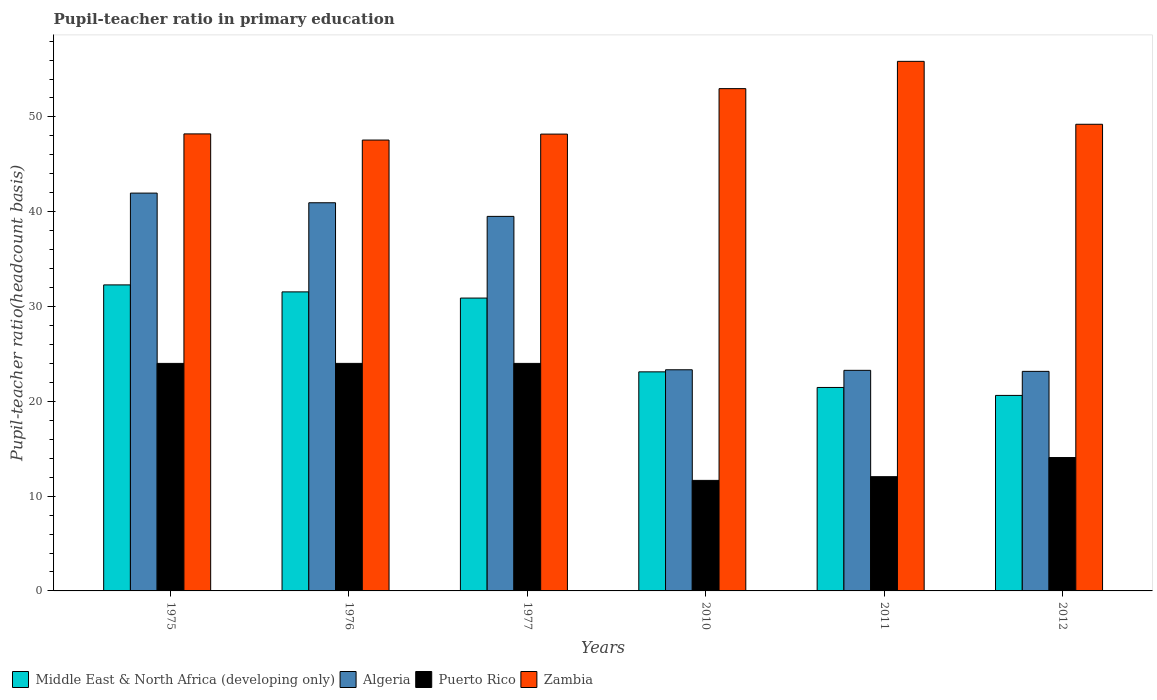How many groups of bars are there?
Provide a short and direct response. 6. Are the number of bars per tick equal to the number of legend labels?
Offer a terse response. Yes. How many bars are there on the 4th tick from the left?
Provide a short and direct response. 4. What is the label of the 1st group of bars from the left?
Ensure brevity in your answer.  1975. What is the pupil-teacher ratio in primary education in Zambia in 2012?
Provide a short and direct response. 49.22. Across all years, what is the maximum pupil-teacher ratio in primary education in Middle East & North Africa (developing only)?
Provide a short and direct response. 32.28. Across all years, what is the minimum pupil-teacher ratio in primary education in Zambia?
Offer a very short reply. 47.56. What is the total pupil-teacher ratio in primary education in Algeria in the graph?
Your response must be concise. 192.18. What is the difference between the pupil-teacher ratio in primary education in Puerto Rico in 2011 and that in 2012?
Make the answer very short. -2.02. What is the difference between the pupil-teacher ratio in primary education in Middle East & North Africa (developing only) in 2010 and the pupil-teacher ratio in primary education in Zambia in 1976?
Provide a short and direct response. -24.45. What is the average pupil-teacher ratio in primary education in Zambia per year?
Offer a terse response. 50.34. In the year 2012, what is the difference between the pupil-teacher ratio in primary education in Middle East & North Africa (developing only) and pupil-teacher ratio in primary education in Puerto Rico?
Ensure brevity in your answer.  6.55. In how many years, is the pupil-teacher ratio in primary education in Algeria greater than 20?
Give a very brief answer. 6. What is the ratio of the pupil-teacher ratio in primary education in Zambia in 1976 to that in 1977?
Offer a very short reply. 0.99. What is the difference between the highest and the second highest pupil-teacher ratio in primary education in Puerto Rico?
Ensure brevity in your answer.  0. What is the difference between the highest and the lowest pupil-teacher ratio in primary education in Algeria?
Your response must be concise. 18.8. In how many years, is the pupil-teacher ratio in primary education in Algeria greater than the average pupil-teacher ratio in primary education in Algeria taken over all years?
Provide a succinct answer. 3. Is it the case that in every year, the sum of the pupil-teacher ratio in primary education in Middle East & North Africa (developing only) and pupil-teacher ratio in primary education in Zambia is greater than the sum of pupil-teacher ratio in primary education in Puerto Rico and pupil-teacher ratio in primary education in Algeria?
Your answer should be compact. Yes. What does the 1st bar from the left in 1977 represents?
Keep it short and to the point. Middle East & North Africa (developing only). What does the 4th bar from the right in 1977 represents?
Give a very brief answer. Middle East & North Africa (developing only). Are all the bars in the graph horizontal?
Keep it short and to the point. No. How many years are there in the graph?
Your answer should be very brief. 6. Does the graph contain grids?
Provide a succinct answer. No. Where does the legend appear in the graph?
Provide a succinct answer. Bottom left. How many legend labels are there?
Offer a terse response. 4. What is the title of the graph?
Your answer should be very brief. Pupil-teacher ratio in primary education. What is the label or title of the X-axis?
Provide a short and direct response. Years. What is the label or title of the Y-axis?
Provide a succinct answer. Pupil-teacher ratio(headcount basis). What is the Pupil-teacher ratio(headcount basis) of Middle East & North Africa (developing only) in 1975?
Your response must be concise. 32.28. What is the Pupil-teacher ratio(headcount basis) in Algeria in 1975?
Provide a short and direct response. 41.96. What is the Pupil-teacher ratio(headcount basis) in Puerto Rico in 1975?
Keep it short and to the point. 24. What is the Pupil-teacher ratio(headcount basis) in Zambia in 1975?
Offer a very short reply. 48.21. What is the Pupil-teacher ratio(headcount basis) of Middle East & North Africa (developing only) in 1976?
Your answer should be compact. 31.55. What is the Pupil-teacher ratio(headcount basis) of Algeria in 1976?
Your answer should be very brief. 40.95. What is the Pupil-teacher ratio(headcount basis) in Puerto Rico in 1976?
Your answer should be very brief. 24. What is the Pupil-teacher ratio(headcount basis) in Zambia in 1976?
Keep it short and to the point. 47.56. What is the Pupil-teacher ratio(headcount basis) of Middle East & North Africa (developing only) in 1977?
Your answer should be very brief. 30.89. What is the Pupil-teacher ratio(headcount basis) of Algeria in 1977?
Offer a terse response. 39.51. What is the Pupil-teacher ratio(headcount basis) in Puerto Rico in 1977?
Your answer should be compact. 24. What is the Pupil-teacher ratio(headcount basis) in Zambia in 1977?
Your answer should be compact. 48.19. What is the Pupil-teacher ratio(headcount basis) in Middle East & North Africa (developing only) in 2010?
Provide a short and direct response. 23.11. What is the Pupil-teacher ratio(headcount basis) of Algeria in 2010?
Make the answer very short. 23.33. What is the Pupil-teacher ratio(headcount basis) of Puerto Rico in 2010?
Make the answer very short. 11.66. What is the Pupil-teacher ratio(headcount basis) in Zambia in 2010?
Keep it short and to the point. 52.99. What is the Pupil-teacher ratio(headcount basis) of Middle East & North Africa (developing only) in 2011?
Offer a very short reply. 21.46. What is the Pupil-teacher ratio(headcount basis) in Algeria in 2011?
Offer a terse response. 23.27. What is the Pupil-teacher ratio(headcount basis) in Puerto Rico in 2011?
Your answer should be compact. 12.05. What is the Pupil-teacher ratio(headcount basis) of Zambia in 2011?
Ensure brevity in your answer.  55.86. What is the Pupil-teacher ratio(headcount basis) in Middle East & North Africa (developing only) in 2012?
Your answer should be compact. 20.62. What is the Pupil-teacher ratio(headcount basis) in Algeria in 2012?
Ensure brevity in your answer.  23.16. What is the Pupil-teacher ratio(headcount basis) of Puerto Rico in 2012?
Your answer should be compact. 14.07. What is the Pupil-teacher ratio(headcount basis) in Zambia in 2012?
Your response must be concise. 49.22. Across all years, what is the maximum Pupil-teacher ratio(headcount basis) in Middle East & North Africa (developing only)?
Make the answer very short. 32.28. Across all years, what is the maximum Pupil-teacher ratio(headcount basis) in Algeria?
Ensure brevity in your answer.  41.96. Across all years, what is the maximum Pupil-teacher ratio(headcount basis) in Puerto Rico?
Give a very brief answer. 24. Across all years, what is the maximum Pupil-teacher ratio(headcount basis) of Zambia?
Provide a succinct answer. 55.86. Across all years, what is the minimum Pupil-teacher ratio(headcount basis) of Middle East & North Africa (developing only)?
Your answer should be compact. 20.62. Across all years, what is the minimum Pupil-teacher ratio(headcount basis) of Algeria?
Give a very brief answer. 23.16. Across all years, what is the minimum Pupil-teacher ratio(headcount basis) of Puerto Rico?
Offer a terse response. 11.66. Across all years, what is the minimum Pupil-teacher ratio(headcount basis) of Zambia?
Provide a succinct answer. 47.56. What is the total Pupil-teacher ratio(headcount basis) in Middle East & North Africa (developing only) in the graph?
Your answer should be compact. 159.91. What is the total Pupil-teacher ratio(headcount basis) of Algeria in the graph?
Give a very brief answer. 192.18. What is the total Pupil-teacher ratio(headcount basis) of Puerto Rico in the graph?
Provide a short and direct response. 109.78. What is the total Pupil-teacher ratio(headcount basis) of Zambia in the graph?
Give a very brief answer. 302.03. What is the difference between the Pupil-teacher ratio(headcount basis) in Middle East & North Africa (developing only) in 1975 and that in 1976?
Provide a succinct answer. 0.74. What is the difference between the Pupil-teacher ratio(headcount basis) of Algeria in 1975 and that in 1976?
Offer a very short reply. 1.02. What is the difference between the Pupil-teacher ratio(headcount basis) in Puerto Rico in 1975 and that in 1976?
Make the answer very short. -0. What is the difference between the Pupil-teacher ratio(headcount basis) of Zambia in 1975 and that in 1976?
Give a very brief answer. 0.65. What is the difference between the Pupil-teacher ratio(headcount basis) of Middle East & North Africa (developing only) in 1975 and that in 1977?
Your response must be concise. 1.39. What is the difference between the Pupil-teacher ratio(headcount basis) of Algeria in 1975 and that in 1977?
Your response must be concise. 2.46. What is the difference between the Pupil-teacher ratio(headcount basis) in Zambia in 1975 and that in 1977?
Ensure brevity in your answer.  0.02. What is the difference between the Pupil-teacher ratio(headcount basis) of Middle East & North Africa (developing only) in 1975 and that in 2010?
Make the answer very short. 9.17. What is the difference between the Pupil-teacher ratio(headcount basis) in Algeria in 1975 and that in 2010?
Your answer should be compact. 18.64. What is the difference between the Pupil-teacher ratio(headcount basis) of Puerto Rico in 1975 and that in 2010?
Offer a very short reply. 12.34. What is the difference between the Pupil-teacher ratio(headcount basis) of Zambia in 1975 and that in 2010?
Your response must be concise. -4.78. What is the difference between the Pupil-teacher ratio(headcount basis) in Middle East & North Africa (developing only) in 1975 and that in 2011?
Offer a very short reply. 10.82. What is the difference between the Pupil-teacher ratio(headcount basis) in Algeria in 1975 and that in 2011?
Keep it short and to the point. 18.7. What is the difference between the Pupil-teacher ratio(headcount basis) of Puerto Rico in 1975 and that in 2011?
Provide a succinct answer. 11.95. What is the difference between the Pupil-teacher ratio(headcount basis) of Zambia in 1975 and that in 2011?
Provide a short and direct response. -7.65. What is the difference between the Pupil-teacher ratio(headcount basis) in Middle East & North Africa (developing only) in 1975 and that in 2012?
Make the answer very short. 11.66. What is the difference between the Pupil-teacher ratio(headcount basis) in Algeria in 1975 and that in 2012?
Provide a succinct answer. 18.8. What is the difference between the Pupil-teacher ratio(headcount basis) of Puerto Rico in 1975 and that in 2012?
Make the answer very short. 9.93. What is the difference between the Pupil-teacher ratio(headcount basis) of Zambia in 1975 and that in 2012?
Ensure brevity in your answer.  -1.02. What is the difference between the Pupil-teacher ratio(headcount basis) in Middle East & North Africa (developing only) in 1976 and that in 1977?
Provide a short and direct response. 0.65. What is the difference between the Pupil-teacher ratio(headcount basis) of Algeria in 1976 and that in 1977?
Provide a short and direct response. 1.44. What is the difference between the Pupil-teacher ratio(headcount basis) in Puerto Rico in 1976 and that in 1977?
Make the answer very short. 0. What is the difference between the Pupil-teacher ratio(headcount basis) of Zambia in 1976 and that in 1977?
Your response must be concise. -0.63. What is the difference between the Pupil-teacher ratio(headcount basis) of Middle East & North Africa (developing only) in 1976 and that in 2010?
Keep it short and to the point. 8.44. What is the difference between the Pupil-teacher ratio(headcount basis) of Algeria in 1976 and that in 2010?
Offer a very short reply. 17.62. What is the difference between the Pupil-teacher ratio(headcount basis) of Puerto Rico in 1976 and that in 2010?
Offer a terse response. 12.34. What is the difference between the Pupil-teacher ratio(headcount basis) of Zambia in 1976 and that in 2010?
Provide a short and direct response. -5.43. What is the difference between the Pupil-teacher ratio(headcount basis) in Middle East & North Africa (developing only) in 1976 and that in 2011?
Provide a short and direct response. 10.08. What is the difference between the Pupil-teacher ratio(headcount basis) of Algeria in 1976 and that in 2011?
Make the answer very short. 17.68. What is the difference between the Pupil-teacher ratio(headcount basis) of Puerto Rico in 1976 and that in 2011?
Your answer should be compact. 11.95. What is the difference between the Pupil-teacher ratio(headcount basis) of Zambia in 1976 and that in 2011?
Give a very brief answer. -8.3. What is the difference between the Pupil-teacher ratio(headcount basis) of Middle East & North Africa (developing only) in 1976 and that in 2012?
Provide a short and direct response. 10.92. What is the difference between the Pupil-teacher ratio(headcount basis) of Algeria in 1976 and that in 2012?
Keep it short and to the point. 17.79. What is the difference between the Pupil-teacher ratio(headcount basis) in Puerto Rico in 1976 and that in 2012?
Provide a short and direct response. 9.93. What is the difference between the Pupil-teacher ratio(headcount basis) of Zambia in 1976 and that in 2012?
Your answer should be very brief. -1.66. What is the difference between the Pupil-teacher ratio(headcount basis) in Middle East & North Africa (developing only) in 1977 and that in 2010?
Provide a short and direct response. 7.78. What is the difference between the Pupil-teacher ratio(headcount basis) in Algeria in 1977 and that in 2010?
Offer a terse response. 16.18. What is the difference between the Pupil-teacher ratio(headcount basis) in Puerto Rico in 1977 and that in 2010?
Keep it short and to the point. 12.34. What is the difference between the Pupil-teacher ratio(headcount basis) in Zambia in 1977 and that in 2010?
Make the answer very short. -4.8. What is the difference between the Pupil-teacher ratio(headcount basis) in Middle East & North Africa (developing only) in 1977 and that in 2011?
Your answer should be compact. 9.43. What is the difference between the Pupil-teacher ratio(headcount basis) of Algeria in 1977 and that in 2011?
Offer a very short reply. 16.24. What is the difference between the Pupil-teacher ratio(headcount basis) of Puerto Rico in 1977 and that in 2011?
Ensure brevity in your answer.  11.95. What is the difference between the Pupil-teacher ratio(headcount basis) in Zambia in 1977 and that in 2011?
Your answer should be compact. -7.67. What is the difference between the Pupil-teacher ratio(headcount basis) of Middle East & North Africa (developing only) in 1977 and that in 2012?
Your answer should be very brief. 10.27. What is the difference between the Pupil-teacher ratio(headcount basis) of Algeria in 1977 and that in 2012?
Offer a terse response. 16.35. What is the difference between the Pupil-teacher ratio(headcount basis) in Puerto Rico in 1977 and that in 2012?
Your answer should be very brief. 9.93. What is the difference between the Pupil-teacher ratio(headcount basis) in Zambia in 1977 and that in 2012?
Your response must be concise. -1.04. What is the difference between the Pupil-teacher ratio(headcount basis) in Middle East & North Africa (developing only) in 2010 and that in 2011?
Your response must be concise. 1.65. What is the difference between the Pupil-teacher ratio(headcount basis) in Algeria in 2010 and that in 2011?
Offer a very short reply. 0.06. What is the difference between the Pupil-teacher ratio(headcount basis) of Puerto Rico in 2010 and that in 2011?
Provide a succinct answer. -0.39. What is the difference between the Pupil-teacher ratio(headcount basis) of Zambia in 2010 and that in 2011?
Give a very brief answer. -2.88. What is the difference between the Pupil-teacher ratio(headcount basis) of Middle East & North Africa (developing only) in 2010 and that in 2012?
Make the answer very short. 2.49. What is the difference between the Pupil-teacher ratio(headcount basis) of Algeria in 2010 and that in 2012?
Provide a succinct answer. 0.17. What is the difference between the Pupil-teacher ratio(headcount basis) of Puerto Rico in 2010 and that in 2012?
Provide a short and direct response. -2.41. What is the difference between the Pupil-teacher ratio(headcount basis) in Zambia in 2010 and that in 2012?
Give a very brief answer. 3.76. What is the difference between the Pupil-teacher ratio(headcount basis) of Middle East & North Africa (developing only) in 2011 and that in 2012?
Your response must be concise. 0.84. What is the difference between the Pupil-teacher ratio(headcount basis) in Algeria in 2011 and that in 2012?
Ensure brevity in your answer.  0.11. What is the difference between the Pupil-teacher ratio(headcount basis) of Puerto Rico in 2011 and that in 2012?
Keep it short and to the point. -2.02. What is the difference between the Pupil-teacher ratio(headcount basis) in Zambia in 2011 and that in 2012?
Your response must be concise. 6.64. What is the difference between the Pupil-teacher ratio(headcount basis) of Middle East & North Africa (developing only) in 1975 and the Pupil-teacher ratio(headcount basis) of Algeria in 1976?
Keep it short and to the point. -8.67. What is the difference between the Pupil-teacher ratio(headcount basis) of Middle East & North Africa (developing only) in 1975 and the Pupil-teacher ratio(headcount basis) of Puerto Rico in 1976?
Make the answer very short. 8.28. What is the difference between the Pupil-teacher ratio(headcount basis) of Middle East & North Africa (developing only) in 1975 and the Pupil-teacher ratio(headcount basis) of Zambia in 1976?
Your response must be concise. -15.28. What is the difference between the Pupil-teacher ratio(headcount basis) of Algeria in 1975 and the Pupil-teacher ratio(headcount basis) of Puerto Rico in 1976?
Ensure brevity in your answer.  17.96. What is the difference between the Pupil-teacher ratio(headcount basis) of Algeria in 1975 and the Pupil-teacher ratio(headcount basis) of Zambia in 1976?
Give a very brief answer. -5.6. What is the difference between the Pupil-teacher ratio(headcount basis) in Puerto Rico in 1975 and the Pupil-teacher ratio(headcount basis) in Zambia in 1976?
Make the answer very short. -23.56. What is the difference between the Pupil-teacher ratio(headcount basis) in Middle East & North Africa (developing only) in 1975 and the Pupil-teacher ratio(headcount basis) in Algeria in 1977?
Your answer should be very brief. -7.23. What is the difference between the Pupil-teacher ratio(headcount basis) of Middle East & North Africa (developing only) in 1975 and the Pupil-teacher ratio(headcount basis) of Puerto Rico in 1977?
Keep it short and to the point. 8.28. What is the difference between the Pupil-teacher ratio(headcount basis) in Middle East & North Africa (developing only) in 1975 and the Pupil-teacher ratio(headcount basis) in Zambia in 1977?
Offer a terse response. -15.91. What is the difference between the Pupil-teacher ratio(headcount basis) in Algeria in 1975 and the Pupil-teacher ratio(headcount basis) in Puerto Rico in 1977?
Provide a succinct answer. 17.96. What is the difference between the Pupil-teacher ratio(headcount basis) in Algeria in 1975 and the Pupil-teacher ratio(headcount basis) in Zambia in 1977?
Your answer should be compact. -6.22. What is the difference between the Pupil-teacher ratio(headcount basis) of Puerto Rico in 1975 and the Pupil-teacher ratio(headcount basis) of Zambia in 1977?
Keep it short and to the point. -24.19. What is the difference between the Pupil-teacher ratio(headcount basis) in Middle East & North Africa (developing only) in 1975 and the Pupil-teacher ratio(headcount basis) in Algeria in 2010?
Offer a terse response. 8.95. What is the difference between the Pupil-teacher ratio(headcount basis) in Middle East & North Africa (developing only) in 1975 and the Pupil-teacher ratio(headcount basis) in Puerto Rico in 2010?
Give a very brief answer. 20.62. What is the difference between the Pupil-teacher ratio(headcount basis) of Middle East & North Africa (developing only) in 1975 and the Pupil-teacher ratio(headcount basis) of Zambia in 2010?
Provide a short and direct response. -20.7. What is the difference between the Pupil-teacher ratio(headcount basis) of Algeria in 1975 and the Pupil-teacher ratio(headcount basis) of Puerto Rico in 2010?
Ensure brevity in your answer.  30.3. What is the difference between the Pupil-teacher ratio(headcount basis) of Algeria in 1975 and the Pupil-teacher ratio(headcount basis) of Zambia in 2010?
Make the answer very short. -11.02. What is the difference between the Pupil-teacher ratio(headcount basis) of Puerto Rico in 1975 and the Pupil-teacher ratio(headcount basis) of Zambia in 2010?
Make the answer very short. -28.98. What is the difference between the Pupil-teacher ratio(headcount basis) in Middle East & North Africa (developing only) in 1975 and the Pupil-teacher ratio(headcount basis) in Algeria in 2011?
Provide a short and direct response. 9.01. What is the difference between the Pupil-teacher ratio(headcount basis) of Middle East & North Africa (developing only) in 1975 and the Pupil-teacher ratio(headcount basis) of Puerto Rico in 2011?
Make the answer very short. 20.23. What is the difference between the Pupil-teacher ratio(headcount basis) in Middle East & North Africa (developing only) in 1975 and the Pupil-teacher ratio(headcount basis) in Zambia in 2011?
Keep it short and to the point. -23.58. What is the difference between the Pupil-teacher ratio(headcount basis) of Algeria in 1975 and the Pupil-teacher ratio(headcount basis) of Puerto Rico in 2011?
Your response must be concise. 29.91. What is the difference between the Pupil-teacher ratio(headcount basis) of Algeria in 1975 and the Pupil-teacher ratio(headcount basis) of Zambia in 2011?
Your answer should be very brief. -13.9. What is the difference between the Pupil-teacher ratio(headcount basis) of Puerto Rico in 1975 and the Pupil-teacher ratio(headcount basis) of Zambia in 2011?
Your answer should be compact. -31.86. What is the difference between the Pupil-teacher ratio(headcount basis) of Middle East & North Africa (developing only) in 1975 and the Pupil-teacher ratio(headcount basis) of Algeria in 2012?
Provide a succinct answer. 9.12. What is the difference between the Pupil-teacher ratio(headcount basis) in Middle East & North Africa (developing only) in 1975 and the Pupil-teacher ratio(headcount basis) in Puerto Rico in 2012?
Give a very brief answer. 18.21. What is the difference between the Pupil-teacher ratio(headcount basis) of Middle East & North Africa (developing only) in 1975 and the Pupil-teacher ratio(headcount basis) of Zambia in 2012?
Make the answer very short. -16.94. What is the difference between the Pupil-teacher ratio(headcount basis) of Algeria in 1975 and the Pupil-teacher ratio(headcount basis) of Puerto Rico in 2012?
Offer a very short reply. 27.89. What is the difference between the Pupil-teacher ratio(headcount basis) of Algeria in 1975 and the Pupil-teacher ratio(headcount basis) of Zambia in 2012?
Your answer should be very brief. -7.26. What is the difference between the Pupil-teacher ratio(headcount basis) in Puerto Rico in 1975 and the Pupil-teacher ratio(headcount basis) in Zambia in 2012?
Give a very brief answer. -25.22. What is the difference between the Pupil-teacher ratio(headcount basis) of Middle East & North Africa (developing only) in 1976 and the Pupil-teacher ratio(headcount basis) of Algeria in 1977?
Your answer should be compact. -7.96. What is the difference between the Pupil-teacher ratio(headcount basis) in Middle East & North Africa (developing only) in 1976 and the Pupil-teacher ratio(headcount basis) in Puerto Rico in 1977?
Provide a short and direct response. 7.54. What is the difference between the Pupil-teacher ratio(headcount basis) of Middle East & North Africa (developing only) in 1976 and the Pupil-teacher ratio(headcount basis) of Zambia in 1977?
Offer a very short reply. -16.64. What is the difference between the Pupil-teacher ratio(headcount basis) in Algeria in 1976 and the Pupil-teacher ratio(headcount basis) in Puerto Rico in 1977?
Give a very brief answer. 16.95. What is the difference between the Pupil-teacher ratio(headcount basis) of Algeria in 1976 and the Pupil-teacher ratio(headcount basis) of Zambia in 1977?
Your answer should be very brief. -7.24. What is the difference between the Pupil-teacher ratio(headcount basis) in Puerto Rico in 1976 and the Pupil-teacher ratio(headcount basis) in Zambia in 1977?
Offer a very short reply. -24.19. What is the difference between the Pupil-teacher ratio(headcount basis) of Middle East & North Africa (developing only) in 1976 and the Pupil-teacher ratio(headcount basis) of Algeria in 2010?
Keep it short and to the point. 8.22. What is the difference between the Pupil-teacher ratio(headcount basis) in Middle East & North Africa (developing only) in 1976 and the Pupil-teacher ratio(headcount basis) in Puerto Rico in 2010?
Your response must be concise. 19.89. What is the difference between the Pupil-teacher ratio(headcount basis) in Middle East & North Africa (developing only) in 1976 and the Pupil-teacher ratio(headcount basis) in Zambia in 2010?
Your response must be concise. -21.44. What is the difference between the Pupil-teacher ratio(headcount basis) in Algeria in 1976 and the Pupil-teacher ratio(headcount basis) in Puerto Rico in 2010?
Offer a terse response. 29.29. What is the difference between the Pupil-teacher ratio(headcount basis) of Algeria in 1976 and the Pupil-teacher ratio(headcount basis) of Zambia in 2010?
Give a very brief answer. -12.04. What is the difference between the Pupil-teacher ratio(headcount basis) in Puerto Rico in 1976 and the Pupil-teacher ratio(headcount basis) in Zambia in 2010?
Ensure brevity in your answer.  -28.98. What is the difference between the Pupil-teacher ratio(headcount basis) of Middle East & North Africa (developing only) in 1976 and the Pupil-teacher ratio(headcount basis) of Algeria in 2011?
Ensure brevity in your answer.  8.28. What is the difference between the Pupil-teacher ratio(headcount basis) of Middle East & North Africa (developing only) in 1976 and the Pupil-teacher ratio(headcount basis) of Puerto Rico in 2011?
Keep it short and to the point. 19.49. What is the difference between the Pupil-teacher ratio(headcount basis) of Middle East & North Africa (developing only) in 1976 and the Pupil-teacher ratio(headcount basis) of Zambia in 2011?
Provide a succinct answer. -24.32. What is the difference between the Pupil-teacher ratio(headcount basis) of Algeria in 1976 and the Pupil-teacher ratio(headcount basis) of Puerto Rico in 2011?
Offer a very short reply. 28.89. What is the difference between the Pupil-teacher ratio(headcount basis) of Algeria in 1976 and the Pupil-teacher ratio(headcount basis) of Zambia in 2011?
Provide a succinct answer. -14.92. What is the difference between the Pupil-teacher ratio(headcount basis) in Puerto Rico in 1976 and the Pupil-teacher ratio(headcount basis) in Zambia in 2011?
Offer a terse response. -31.86. What is the difference between the Pupil-teacher ratio(headcount basis) of Middle East & North Africa (developing only) in 1976 and the Pupil-teacher ratio(headcount basis) of Algeria in 2012?
Your answer should be very brief. 8.39. What is the difference between the Pupil-teacher ratio(headcount basis) of Middle East & North Africa (developing only) in 1976 and the Pupil-teacher ratio(headcount basis) of Puerto Rico in 2012?
Your answer should be very brief. 17.48. What is the difference between the Pupil-teacher ratio(headcount basis) in Middle East & North Africa (developing only) in 1976 and the Pupil-teacher ratio(headcount basis) in Zambia in 2012?
Your response must be concise. -17.68. What is the difference between the Pupil-teacher ratio(headcount basis) of Algeria in 1976 and the Pupil-teacher ratio(headcount basis) of Puerto Rico in 2012?
Offer a very short reply. 26.88. What is the difference between the Pupil-teacher ratio(headcount basis) of Algeria in 1976 and the Pupil-teacher ratio(headcount basis) of Zambia in 2012?
Make the answer very short. -8.28. What is the difference between the Pupil-teacher ratio(headcount basis) in Puerto Rico in 1976 and the Pupil-teacher ratio(headcount basis) in Zambia in 2012?
Provide a succinct answer. -25.22. What is the difference between the Pupil-teacher ratio(headcount basis) in Middle East & North Africa (developing only) in 1977 and the Pupil-teacher ratio(headcount basis) in Algeria in 2010?
Your answer should be very brief. 7.56. What is the difference between the Pupil-teacher ratio(headcount basis) in Middle East & North Africa (developing only) in 1977 and the Pupil-teacher ratio(headcount basis) in Puerto Rico in 2010?
Offer a terse response. 19.23. What is the difference between the Pupil-teacher ratio(headcount basis) in Middle East & North Africa (developing only) in 1977 and the Pupil-teacher ratio(headcount basis) in Zambia in 2010?
Provide a succinct answer. -22.09. What is the difference between the Pupil-teacher ratio(headcount basis) of Algeria in 1977 and the Pupil-teacher ratio(headcount basis) of Puerto Rico in 2010?
Your response must be concise. 27.85. What is the difference between the Pupil-teacher ratio(headcount basis) in Algeria in 1977 and the Pupil-teacher ratio(headcount basis) in Zambia in 2010?
Make the answer very short. -13.48. What is the difference between the Pupil-teacher ratio(headcount basis) in Puerto Rico in 1977 and the Pupil-teacher ratio(headcount basis) in Zambia in 2010?
Your answer should be compact. -28.98. What is the difference between the Pupil-teacher ratio(headcount basis) in Middle East & North Africa (developing only) in 1977 and the Pupil-teacher ratio(headcount basis) in Algeria in 2011?
Ensure brevity in your answer.  7.62. What is the difference between the Pupil-teacher ratio(headcount basis) of Middle East & North Africa (developing only) in 1977 and the Pupil-teacher ratio(headcount basis) of Puerto Rico in 2011?
Your response must be concise. 18.84. What is the difference between the Pupil-teacher ratio(headcount basis) in Middle East & North Africa (developing only) in 1977 and the Pupil-teacher ratio(headcount basis) in Zambia in 2011?
Ensure brevity in your answer.  -24.97. What is the difference between the Pupil-teacher ratio(headcount basis) in Algeria in 1977 and the Pupil-teacher ratio(headcount basis) in Puerto Rico in 2011?
Your answer should be very brief. 27.46. What is the difference between the Pupil-teacher ratio(headcount basis) in Algeria in 1977 and the Pupil-teacher ratio(headcount basis) in Zambia in 2011?
Your answer should be compact. -16.35. What is the difference between the Pupil-teacher ratio(headcount basis) of Puerto Rico in 1977 and the Pupil-teacher ratio(headcount basis) of Zambia in 2011?
Your response must be concise. -31.86. What is the difference between the Pupil-teacher ratio(headcount basis) in Middle East & North Africa (developing only) in 1977 and the Pupil-teacher ratio(headcount basis) in Algeria in 2012?
Your answer should be very brief. 7.73. What is the difference between the Pupil-teacher ratio(headcount basis) in Middle East & North Africa (developing only) in 1977 and the Pupil-teacher ratio(headcount basis) in Puerto Rico in 2012?
Keep it short and to the point. 16.82. What is the difference between the Pupil-teacher ratio(headcount basis) of Middle East & North Africa (developing only) in 1977 and the Pupil-teacher ratio(headcount basis) of Zambia in 2012?
Offer a very short reply. -18.33. What is the difference between the Pupil-teacher ratio(headcount basis) in Algeria in 1977 and the Pupil-teacher ratio(headcount basis) in Puerto Rico in 2012?
Offer a terse response. 25.44. What is the difference between the Pupil-teacher ratio(headcount basis) in Algeria in 1977 and the Pupil-teacher ratio(headcount basis) in Zambia in 2012?
Provide a succinct answer. -9.72. What is the difference between the Pupil-teacher ratio(headcount basis) in Puerto Rico in 1977 and the Pupil-teacher ratio(headcount basis) in Zambia in 2012?
Provide a succinct answer. -25.22. What is the difference between the Pupil-teacher ratio(headcount basis) in Middle East & North Africa (developing only) in 2010 and the Pupil-teacher ratio(headcount basis) in Algeria in 2011?
Give a very brief answer. -0.16. What is the difference between the Pupil-teacher ratio(headcount basis) in Middle East & North Africa (developing only) in 2010 and the Pupil-teacher ratio(headcount basis) in Puerto Rico in 2011?
Your response must be concise. 11.06. What is the difference between the Pupil-teacher ratio(headcount basis) of Middle East & North Africa (developing only) in 2010 and the Pupil-teacher ratio(headcount basis) of Zambia in 2011?
Offer a very short reply. -32.75. What is the difference between the Pupil-teacher ratio(headcount basis) of Algeria in 2010 and the Pupil-teacher ratio(headcount basis) of Puerto Rico in 2011?
Keep it short and to the point. 11.28. What is the difference between the Pupil-teacher ratio(headcount basis) in Algeria in 2010 and the Pupil-teacher ratio(headcount basis) in Zambia in 2011?
Your answer should be very brief. -32.53. What is the difference between the Pupil-teacher ratio(headcount basis) of Puerto Rico in 2010 and the Pupil-teacher ratio(headcount basis) of Zambia in 2011?
Ensure brevity in your answer.  -44.2. What is the difference between the Pupil-teacher ratio(headcount basis) in Middle East & North Africa (developing only) in 2010 and the Pupil-teacher ratio(headcount basis) in Puerto Rico in 2012?
Provide a short and direct response. 9.04. What is the difference between the Pupil-teacher ratio(headcount basis) in Middle East & North Africa (developing only) in 2010 and the Pupil-teacher ratio(headcount basis) in Zambia in 2012?
Your answer should be very brief. -26.11. What is the difference between the Pupil-teacher ratio(headcount basis) in Algeria in 2010 and the Pupil-teacher ratio(headcount basis) in Puerto Rico in 2012?
Provide a short and direct response. 9.26. What is the difference between the Pupil-teacher ratio(headcount basis) of Algeria in 2010 and the Pupil-teacher ratio(headcount basis) of Zambia in 2012?
Offer a terse response. -25.9. What is the difference between the Pupil-teacher ratio(headcount basis) of Puerto Rico in 2010 and the Pupil-teacher ratio(headcount basis) of Zambia in 2012?
Your answer should be compact. -37.56. What is the difference between the Pupil-teacher ratio(headcount basis) of Middle East & North Africa (developing only) in 2011 and the Pupil-teacher ratio(headcount basis) of Algeria in 2012?
Provide a succinct answer. -1.7. What is the difference between the Pupil-teacher ratio(headcount basis) of Middle East & North Africa (developing only) in 2011 and the Pupil-teacher ratio(headcount basis) of Puerto Rico in 2012?
Offer a very short reply. 7.39. What is the difference between the Pupil-teacher ratio(headcount basis) of Middle East & North Africa (developing only) in 2011 and the Pupil-teacher ratio(headcount basis) of Zambia in 2012?
Ensure brevity in your answer.  -27.76. What is the difference between the Pupil-teacher ratio(headcount basis) of Algeria in 2011 and the Pupil-teacher ratio(headcount basis) of Puerto Rico in 2012?
Make the answer very short. 9.2. What is the difference between the Pupil-teacher ratio(headcount basis) in Algeria in 2011 and the Pupil-teacher ratio(headcount basis) in Zambia in 2012?
Your response must be concise. -25.96. What is the difference between the Pupil-teacher ratio(headcount basis) of Puerto Rico in 2011 and the Pupil-teacher ratio(headcount basis) of Zambia in 2012?
Your answer should be compact. -37.17. What is the average Pupil-teacher ratio(headcount basis) in Middle East & North Africa (developing only) per year?
Your answer should be compact. 26.65. What is the average Pupil-teacher ratio(headcount basis) in Algeria per year?
Keep it short and to the point. 32.03. What is the average Pupil-teacher ratio(headcount basis) of Puerto Rico per year?
Offer a very short reply. 18.3. What is the average Pupil-teacher ratio(headcount basis) of Zambia per year?
Give a very brief answer. 50.34. In the year 1975, what is the difference between the Pupil-teacher ratio(headcount basis) of Middle East & North Africa (developing only) and Pupil-teacher ratio(headcount basis) of Algeria?
Keep it short and to the point. -9.68. In the year 1975, what is the difference between the Pupil-teacher ratio(headcount basis) of Middle East & North Africa (developing only) and Pupil-teacher ratio(headcount basis) of Puerto Rico?
Provide a short and direct response. 8.28. In the year 1975, what is the difference between the Pupil-teacher ratio(headcount basis) in Middle East & North Africa (developing only) and Pupil-teacher ratio(headcount basis) in Zambia?
Your answer should be compact. -15.93. In the year 1975, what is the difference between the Pupil-teacher ratio(headcount basis) in Algeria and Pupil-teacher ratio(headcount basis) in Puerto Rico?
Your answer should be very brief. 17.96. In the year 1975, what is the difference between the Pupil-teacher ratio(headcount basis) in Algeria and Pupil-teacher ratio(headcount basis) in Zambia?
Provide a succinct answer. -6.24. In the year 1975, what is the difference between the Pupil-teacher ratio(headcount basis) of Puerto Rico and Pupil-teacher ratio(headcount basis) of Zambia?
Offer a very short reply. -24.21. In the year 1976, what is the difference between the Pupil-teacher ratio(headcount basis) in Middle East & North Africa (developing only) and Pupil-teacher ratio(headcount basis) in Algeria?
Offer a very short reply. -9.4. In the year 1976, what is the difference between the Pupil-teacher ratio(headcount basis) in Middle East & North Africa (developing only) and Pupil-teacher ratio(headcount basis) in Puerto Rico?
Give a very brief answer. 7.54. In the year 1976, what is the difference between the Pupil-teacher ratio(headcount basis) in Middle East & North Africa (developing only) and Pupil-teacher ratio(headcount basis) in Zambia?
Keep it short and to the point. -16.01. In the year 1976, what is the difference between the Pupil-teacher ratio(headcount basis) in Algeria and Pupil-teacher ratio(headcount basis) in Puerto Rico?
Your response must be concise. 16.94. In the year 1976, what is the difference between the Pupil-teacher ratio(headcount basis) of Algeria and Pupil-teacher ratio(headcount basis) of Zambia?
Offer a very short reply. -6.61. In the year 1976, what is the difference between the Pupil-teacher ratio(headcount basis) of Puerto Rico and Pupil-teacher ratio(headcount basis) of Zambia?
Offer a terse response. -23.56. In the year 1977, what is the difference between the Pupil-teacher ratio(headcount basis) in Middle East & North Africa (developing only) and Pupil-teacher ratio(headcount basis) in Algeria?
Provide a succinct answer. -8.62. In the year 1977, what is the difference between the Pupil-teacher ratio(headcount basis) in Middle East & North Africa (developing only) and Pupil-teacher ratio(headcount basis) in Puerto Rico?
Offer a very short reply. 6.89. In the year 1977, what is the difference between the Pupil-teacher ratio(headcount basis) in Middle East & North Africa (developing only) and Pupil-teacher ratio(headcount basis) in Zambia?
Provide a short and direct response. -17.3. In the year 1977, what is the difference between the Pupil-teacher ratio(headcount basis) in Algeria and Pupil-teacher ratio(headcount basis) in Puerto Rico?
Your response must be concise. 15.51. In the year 1977, what is the difference between the Pupil-teacher ratio(headcount basis) in Algeria and Pupil-teacher ratio(headcount basis) in Zambia?
Your answer should be compact. -8.68. In the year 1977, what is the difference between the Pupil-teacher ratio(headcount basis) in Puerto Rico and Pupil-teacher ratio(headcount basis) in Zambia?
Provide a short and direct response. -24.19. In the year 2010, what is the difference between the Pupil-teacher ratio(headcount basis) in Middle East & North Africa (developing only) and Pupil-teacher ratio(headcount basis) in Algeria?
Make the answer very short. -0.22. In the year 2010, what is the difference between the Pupil-teacher ratio(headcount basis) in Middle East & North Africa (developing only) and Pupil-teacher ratio(headcount basis) in Puerto Rico?
Provide a short and direct response. 11.45. In the year 2010, what is the difference between the Pupil-teacher ratio(headcount basis) of Middle East & North Africa (developing only) and Pupil-teacher ratio(headcount basis) of Zambia?
Your answer should be very brief. -29.88. In the year 2010, what is the difference between the Pupil-teacher ratio(headcount basis) in Algeria and Pupil-teacher ratio(headcount basis) in Puerto Rico?
Offer a terse response. 11.67. In the year 2010, what is the difference between the Pupil-teacher ratio(headcount basis) in Algeria and Pupil-teacher ratio(headcount basis) in Zambia?
Ensure brevity in your answer.  -29.66. In the year 2010, what is the difference between the Pupil-teacher ratio(headcount basis) of Puerto Rico and Pupil-teacher ratio(headcount basis) of Zambia?
Your response must be concise. -41.33. In the year 2011, what is the difference between the Pupil-teacher ratio(headcount basis) of Middle East & North Africa (developing only) and Pupil-teacher ratio(headcount basis) of Algeria?
Provide a succinct answer. -1.81. In the year 2011, what is the difference between the Pupil-teacher ratio(headcount basis) of Middle East & North Africa (developing only) and Pupil-teacher ratio(headcount basis) of Puerto Rico?
Give a very brief answer. 9.41. In the year 2011, what is the difference between the Pupil-teacher ratio(headcount basis) of Middle East & North Africa (developing only) and Pupil-teacher ratio(headcount basis) of Zambia?
Give a very brief answer. -34.4. In the year 2011, what is the difference between the Pupil-teacher ratio(headcount basis) in Algeria and Pupil-teacher ratio(headcount basis) in Puerto Rico?
Give a very brief answer. 11.22. In the year 2011, what is the difference between the Pupil-teacher ratio(headcount basis) of Algeria and Pupil-teacher ratio(headcount basis) of Zambia?
Offer a very short reply. -32.59. In the year 2011, what is the difference between the Pupil-teacher ratio(headcount basis) of Puerto Rico and Pupil-teacher ratio(headcount basis) of Zambia?
Your response must be concise. -43.81. In the year 2012, what is the difference between the Pupil-teacher ratio(headcount basis) in Middle East & North Africa (developing only) and Pupil-teacher ratio(headcount basis) in Algeria?
Keep it short and to the point. -2.54. In the year 2012, what is the difference between the Pupil-teacher ratio(headcount basis) in Middle East & North Africa (developing only) and Pupil-teacher ratio(headcount basis) in Puerto Rico?
Provide a short and direct response. 6.55. In the year 2012, what is the difference between the Pupil-teacher ratio(headcount basis) in Middle East & North Africa (developing only) and Pupil-teacher ratio(headcount basis) in Zambia?
Your response must be concise. -28.6. In the year 2012, what is the difference between the Pupil-teacher ratio(headcount basis) of Algeria and Pupil-teacher ratio(headcount basis) of Puerto Rico?
Your answer should be very brief. 9.09. In the year 2012, what is the difference between the Pupil-teacher ratio(headcount basis) in Algeria and Pupil-teacher ratio(headcount basis) in Zambia?
Your answer should be very brief. -26.06. In the year 2012, what is the difference between the Pupil-teacher ratio(headcount basis) in Puerto Rico and Pupil-teacher ratio(headcount basis) in Zambia?
Provide a short and direct response. -35.15. What is the ratio of the Pupil-teacher ratio(headcount basis) of Middle East & North Africa (developing only) in 1975 to that in 1976?
Your response must be concise. 1.02. What is the ratio of the Pupil-teacher ratio(headcount basis) of Algeria in 1975 to that in 1976?
Offer a very short reply. 1.02. What is the ratio of the Pupil-teacher ratio(headcount basis) of Puerto Rico in 1975 to that in 1976?
Offer a terse response. 1. What is the ratio of the Pupil-teacher ratio(headcount basis) in Zambia in 1975 to that in 1976?
Keep it short and to the point. 1.01. What is the ratio of the Pupil-teacher ratio(headcount basis) of Middle East & North Africa (developing only) in 1975 to that in 1977?
Your answer should be compact. 1.04. What is the ratio of the Pupil-teacher ratio(headcount basis) in Algeria in 1975 to that in 1977?
Give a very brief answer. 1.06. What is the ratio of the Pupil-teacher ratio(headcount basis) in Puerto Rico in 1975 to that in 1977?
Your answer should be compact. 1. What is the ratio of the Pupil-teacher ratio(headcount basis) in Zambia in 1975 to that in 1977?
Your response must be concise. 1. What is the ratio of the Pupil-teacher ratio(headcount basis) of Middle East & North Africa (developing only) in 1975 to that in 2010?
Your answer should be very brief. 1.4. What is the ratio of the Pupil-teacher ratio(headcount basis) in Algeria in 1975 to that in 2010?
Your answer should be compact. 1.8. What is the ratio of the Pupil-teacher ratio(headcount basis) in Puerto Rico in 1975 to that in 2010?
Offer a terse response. 2.06. What is the ratio of the Pupil-teacher ratio(headcount basis) of Zambia in 1975 to that in 2010?
Offer a terse response. 0.91. What is the ratio of the Pupil-teacher ratio(headcount basis) in Middle East & North Africa (developing only) in 1975 to that in 2011?
Keep it short and to the point. 1.5. What is the ratio of the Pupil-teacher ratio(headcount basis) of Algeria in 1975 to that in 2011?
Your answer should be compact. 1.8. What is the ratio of the Pupil-teacher ratio(headcount basis) of Puerto Rico in 1975 to that in 2011?
Your answer should be compact. 1.99. What is the ratio of the Pupil-teacher ratio(headcount basis) in Zambia in 1975 to that in 2011?
Your response must be concise. 0.86. What is the ratio of the Pupil-teacher ratio(headcount basis) in Middle East & North Africa (developing only) in 1975 to that in 2012?
Your answer should be very brief. 1.57. What is the ratio of the Pupil-teacher ratio(headcount basis) of Algeria in 1975 to that in 2012?
Keep it short and to the point. 1.81. What is the ratio of the Pupil-teacher ratio(headcount basis) in Puerto Rico in 1975 to that in 2012?
Offer a very short reply. 1.71. What is the ratio of the Pupil-teacher ratio(headcount basis) of Zambia in 1975 to that in 2012?
Ensure brevity in your answer.  0.98. What is the ratio of the Pupil-teacher ratio(headcount basis) in Middle East & North Africa (developing only) in 1976 to that in 1977?
Make the answer very short. 1.02. What is the ratio of the Pupil-teacher ratio(headcount basis) in Algeria in 1976 to that in 1977?
Provide a short and direct response. 1.04. What is the ratio of the Pupil-teacher ratio(headcount basis) in Puerto Rico in 1976 to that in 1977?
Provide a short and direct response. 1. What is the ratio of the Pupil-teacher ratio(headcount basis) in Middle East & North Africa (developing only) in 1976 to that in 2010?
Provide a short and direct response. 1.36. What is the ratio of the Pupil-teacher ratio(headcount basis) in Algeria in 1976 to that in 2010?
Ensure brevity in your answer.  1.76. What is the ratio of the Pupil-teacher ratio(headcount basis) of Puerto Rico in 1976 to that in 2010?
Your response must be concise. 2.06. What is the ratio of the Pupil-teacher ratio(headcount basis) in Zambia in 1976 to that in 2010?
Your response must be concise. 0.9. What is the ratio of the Pupil-teacher ratio(headcount basis) in Middle East & North Africa (developing only) in 1976 to that in 2011?
Offer a very short reply. 1.47. What is the ratio of the Pupil-teacher ratio(headcount basis) in Algeria in 1976 to that in 2011?
Ensure brevity in your answer.  1.76. What is the ratio of the Pupil-teacher ratio(headcount basis) of Puerto Rico in 1976 to that in 2011?
Give a very brief answer. 1.99. What is the ratio of the Pupil-teacher ratio(headcount basis) of Zambia in 1976 to that in 2011?
Ensure brevity in your answer.  0.85. What is the ratio of the Pupil-teacher ratio(headcount basis) of Middle East & North Africa (developing only) in 1976 to that in 2012?
Offer a very short reply. 1.53. What is the ratio of the Pupil-teacher ratio(headcount basis) of Algeria in 1976 to that in 2012?
Your response must be concise. 1.77. What is the ratio of the Pupil-teacher ratio(headcount basis) of Puerto Rico in 1976 to that in 2012?
Offer a very short reply. 1.71. What is the ratio of the Pupil-teacher ratio(headcount basis) in Zambia in 1976 to that in 2012?
Your answer should be compact. 0.97. What is the ratio of the Pupil-teacher ratio(headcount basis) of Middle East & North Africa (developing only) in 1977 to that in 2010?
Your response must be concise. 1.34. What is the ratio of the Pupil-teacher ratio(headcount basis) of Algeria in 1977 to that in 2010?
Your answer should be very brief. 1.69. What is the ratio of the Pupil-teacher ratio(headcount basis) of Puerto Rico in 1977 to that in 2010?
Ensure brevity in your answer.  2.06. What is the ratio of the Pupil-teacher ratio(headcount basis) of Zambia in 1977 to that in 2010?
Provide a succinct answer. 0.91. What is the ratio of the Pupil-teacher ratio(headcount basis) of Middle East & North Africa (developing only) in 1977 to that in 2011?
Your answer should be very brief. 1.44. What is the ratio of the Pupil-teacher ratio(headcount basis) of Algeria in 1977 to that in 2011?
Your answer should be compact. 1.7. What is the ratio of the Pupil-teacher ratio(headcount basis) in Puerto Rico in 1977 to that in 2011?
Keep it short and to the point. 1.99. What is the ratio of the Pupil-teacher ratio(headcount basis) of Zambia in 1977 to that in 2011?
Give a very brief answer. 0.86. What is the ratio of the Pupil-teacher ratio(headcount basis) of Middle East & North Africa (developing only) in 1977 to that in 2012?
Provide a short and direct response. 1.5. What is the ratio of the Pupil-teacher ratio(headcount basis) of Algeria in 1977 to that in 2012?
Ensure brevity in your answer.  1.71. What is the ratio of the Pupil-teacher ratio(headcount basis) of Puerto Rico in 1977 to that in 2012?
Ensure brevity in your answer.  1.71. What is the ratio of the Pupil-teacher ratio(headcount basis) in Zambia in 1977 to that in 2012?
Your answer should be very brief. 0.98. What is the ratio of the Pupil-teacher ratio(headcount basis) in Middle East & North Africa (developing only) in 2010 to that in 2011?
Give a very brief answer. 1.08. What is the ratio of the Pupil-teacher ratio(headcount basis) in Algeria in 2010 to that in 2011?
Offer a very short reply. 1. What is the ratio of the Pupil-teacher ratio(headcount basis) in Puerto Rico in 2010 to that in 2011?
Offer a terse response. 0.97. What is the ratio of the Pupil-teacher ratio(headcount basis) in Zambia in 2010 to that in 2011?
Your response must be concise. 0.95. What is the ratio of the Pupil-teacher ratio(headcount basis) of Middle East & North Africa (developing only) in 2010 to that in 2012?
Your answer should be very brief. 1.12. What is the ratio of the Pupil-teacher ratio(headcount basis) of Algeria in 2010 to that in 2012?
Give a very brief answer. 1.01. What is the ratio of the Pupil-teacher ratio(headcount basis) of Puerto Rico in 2010 to that in 2012?
Your answer should be very brief. 0.83. What is the ratio of the Pupil-teacher ratio(headcount basis) of Zambia in 2010 to that in 2012?
Ensure brevity in your answer.  1.08. What is the ratio of the Pupil-teacher ratio(headcount basis) in Middle East & North Africa (developing only) in 2011 to that in 2012?
Offer a terse response. 1.04. What is the ratio of the Pupil-teacher ratio(headcount basis) in Algeria in 2011 to that in 2012?
Provide a succinct answer. 1. What is the ratio of the Pupil-teacher ratio(headcount basis) in Puerto Rico in 2011 to that in 2012?
Your answer should be compact. 0.86. What is the ratio of the Pupil-teacher ratio(headcount basis) of Zambia in 2011 to that in 2012?
Offer a terse response. 1.13. What is the difference between the highest and the second highest Pupil-teacher ratio(headcount basis) of Middle East & North Africa (developing only)?
Provide a short and direct response. 0.74. What is the difference between the highest and the second highest Pupil-teacher ratio(headcount basis) of Algeria?
Offer a very short reply. 1.02. What is the difference between the highest and the second highest Pupil-teacher ratio(headcount basis) in Puerto Rico?
Ensure brevity in your answer.  0. What is the difference between the highest and the second highest Pupil-teacher ratio(headcount basis) in Zambia?
Make the answer very short. 2.88. What is the difference between the highest and the lowest Pupil-teacher ratio(headcount basis) of Middle East & North Africa (developing only)?
Provide a short and direct response. 11.66. What is the difference between the highest and the lowest Pupil-teacher ratio(headcount basis) of Algeria?
Provide a succinct answer. 18.8. What is the difference between the highest and the lowest Pupil-teacher ratio(headcount basis) in Puerto Rico?
Offer a terse response. 12.34. What is the difference between the highest and the lowest Pupil-teacher ratio(headcount basis) in Zambia?
Offer a very short reply. 8.3. 